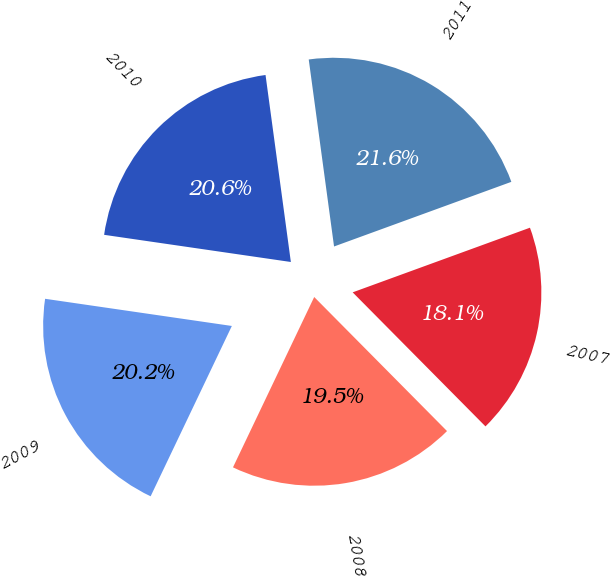Convert chart to OTSL. <chart><loc_0><loc_0><loc_500><loc_500><pie_chart><fcel>2011<fcel>2010<fcel>2009<fcel>2008<fcel>2007<nl><fcel>21.58%<fcel>20.56%<fcel>20.22%<fcel>19.51%<fcel>18.14%<nl></chart> 